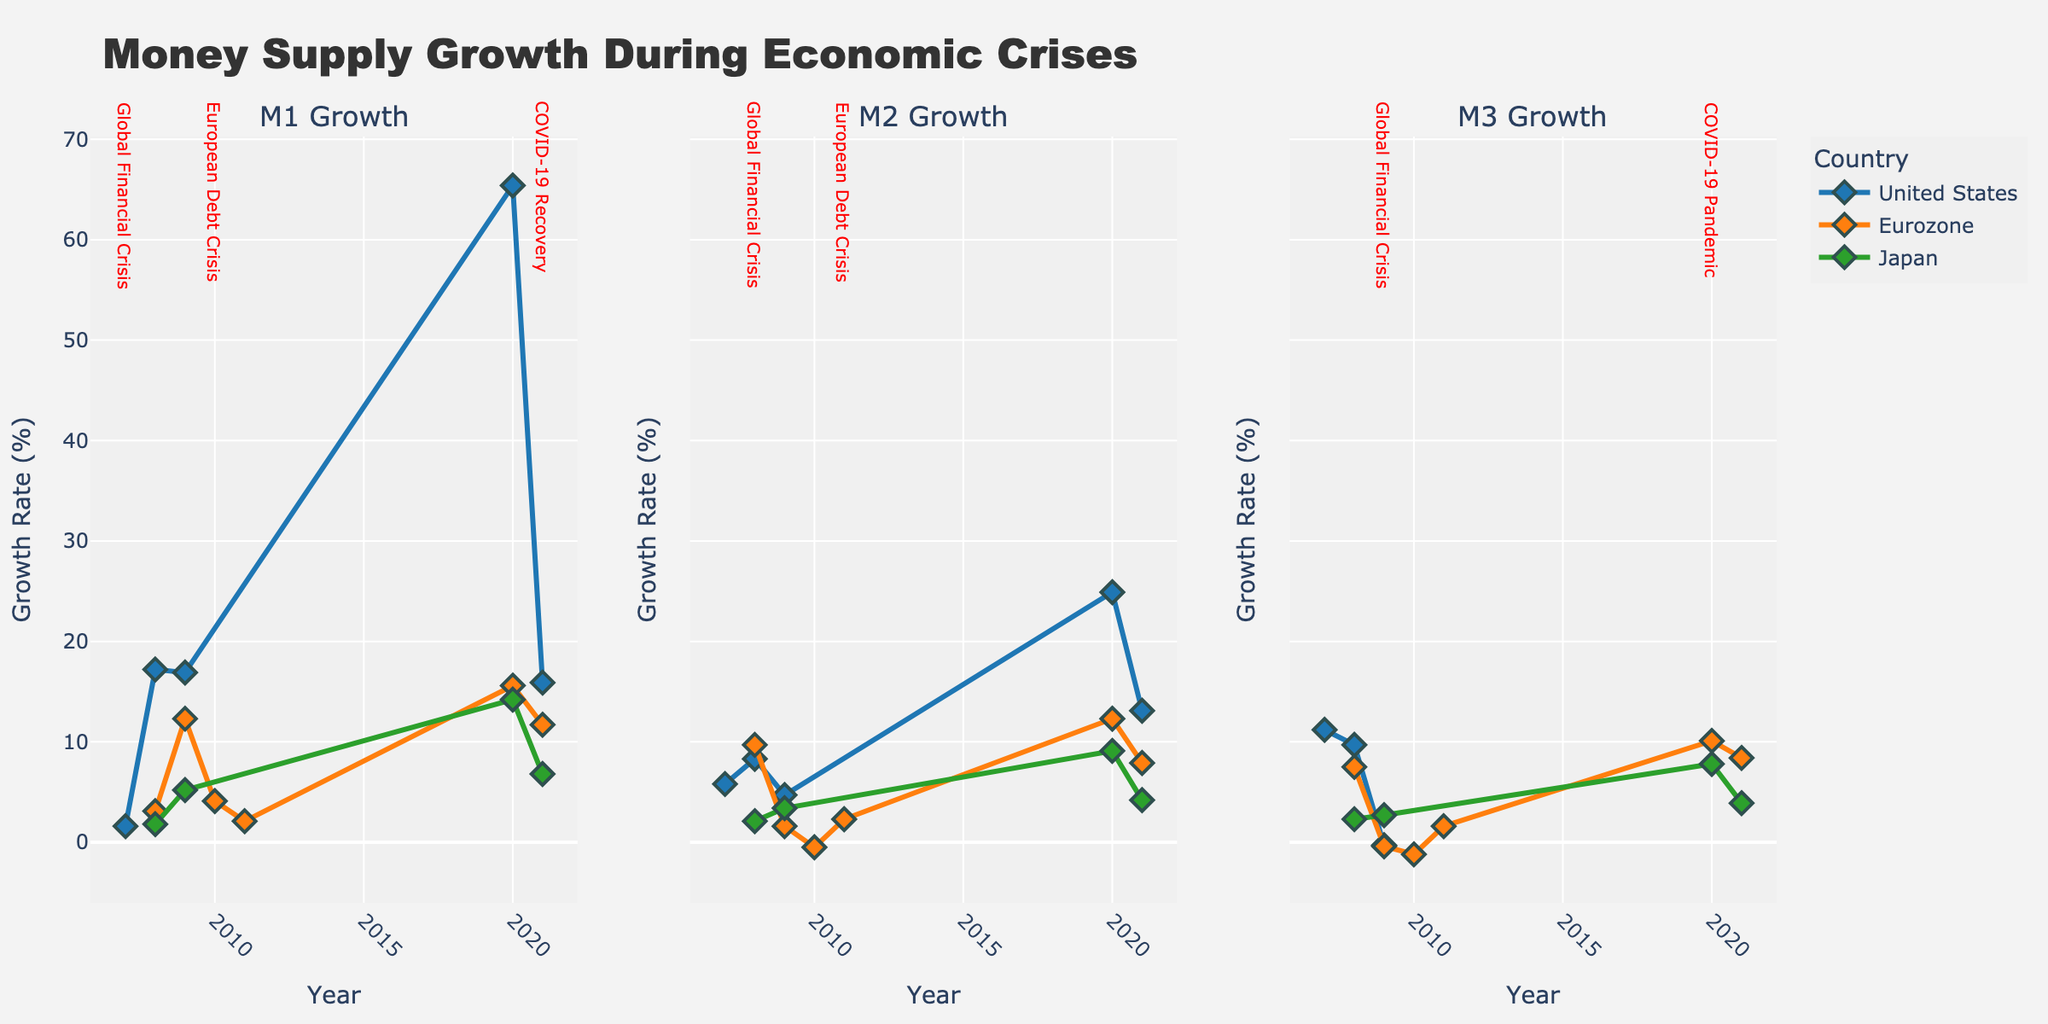what is the title of the figure? The title of the figure is typically located at the top of the plot. In this case, it reads "Money Supply Growth During Economic Crises"
Answer: Money Supply Growth During Economic Crises What do the colors represent in the figure? The colors represent different countries: blue for the United States, orange for Eurozone, and green for Japan, as seen from the figure's differentiation
Answer: Countries Which country had the highest M1 growth in 2020? Observe the subplots and find the one labeled "M1 Growth." Look for the elements in the year 2020 and compare the values for each country. The United States shows the highest value.
Answer: United States Which country showed a negative growth rate for M2 in 2010, and how much was it? Check the subplot labeled "M2 Growth" for the year 2010. Eurozone shows a negative value, which is approximately -0.5%
Answer: Eurozone, -0.5% During the Global Financial Crisis, which country experienced a decrease in M3 growth in 2009 compared to 2008? Look at the subplots labeled "M3 Growth" and compare the values from 2008 to 2009 for each country involved in the Global Financial Crisis. Both the United States and the Eurozone show a decrease, while Japan shows an increase.
Answer: United States and Eurozone What's the overall trend of M1 growth in the United States during the COVID-19 Pandemic and Recovery? Look for the "M1 Growth" subplot and observe the United States line from 2020 to 2021. It shows a significant increase in 2020 and a reduction nearly by half in 2021
Answer: Increase in 2020, Reduction in 2021 Compare the M2 growth in Japan during the COVID-19 Pandemic and Recovery. Which year had a higher growth rate? Look at the subplot "M2 Growth" and observe Japan's values in 2020 and 2021. The rate in 2020 is higher than in 2021
Answer: 2020 What's the M3 growth rate in the Eurozone for the years 2008 and 2009? Observe the subplot labeled "M3 Growth" and find the Eurozone data points for years 2008 and 2009. The values are 7.5% for 2008 and -0.4% for 2009
Answer: 7.5%, -0.4% How did the Euro crisis affect money supply growth (M1, M2, M3) in the Eurozone from 2010 to 2011? Look at the subplots for M1, M2, and M3 growth. In M1 growth, there was a slight increase from 4.1% in 2010 to 2.1% in 2011. For M2, it changed from -0.5% in 2010 to 2.3% in 2011, and for M3, it went from -1.2% in 2010 to 1.6% in 2011
Answer: M1: increase, M2: increase, M3: increase 